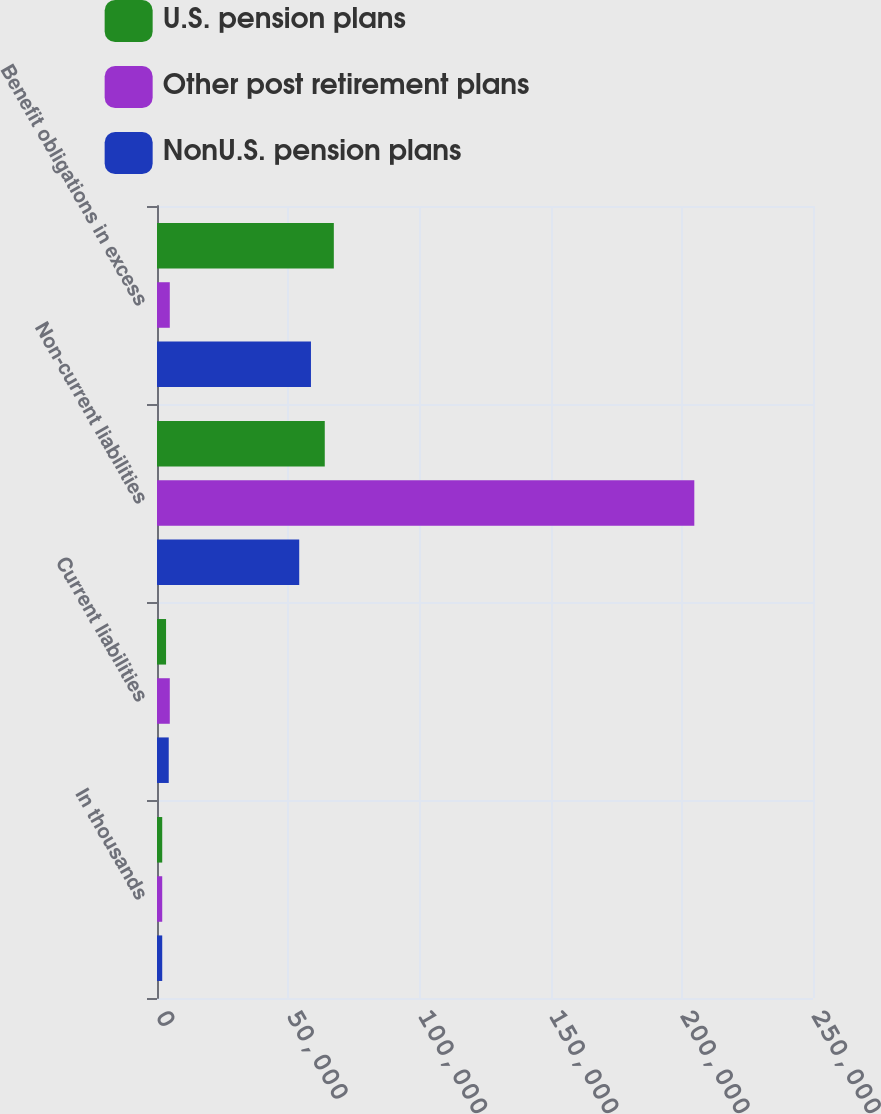Convert chart to OTSL. <chart><loc_0><loc_0><loc_500><loc_500><stacked_bar_chart><ecel><fcel>In thousands<fcel>Current liabilities<fcel>Non-current liabilities<fcel>Benefit obligations in excess<nl><fcel>U.S. pension plans<fcel>2012<fcel>3490<fcel>64614<fcel>68104<nl><fcel>Other post retirement plans<fcel>2012<fcel>4925<fcel>206942<fcel>4925<nl><fcel>NonU.S. pension plans<fcel>2012<fcel>4520<fcel>54777<fcel>59297<nl></chart> 